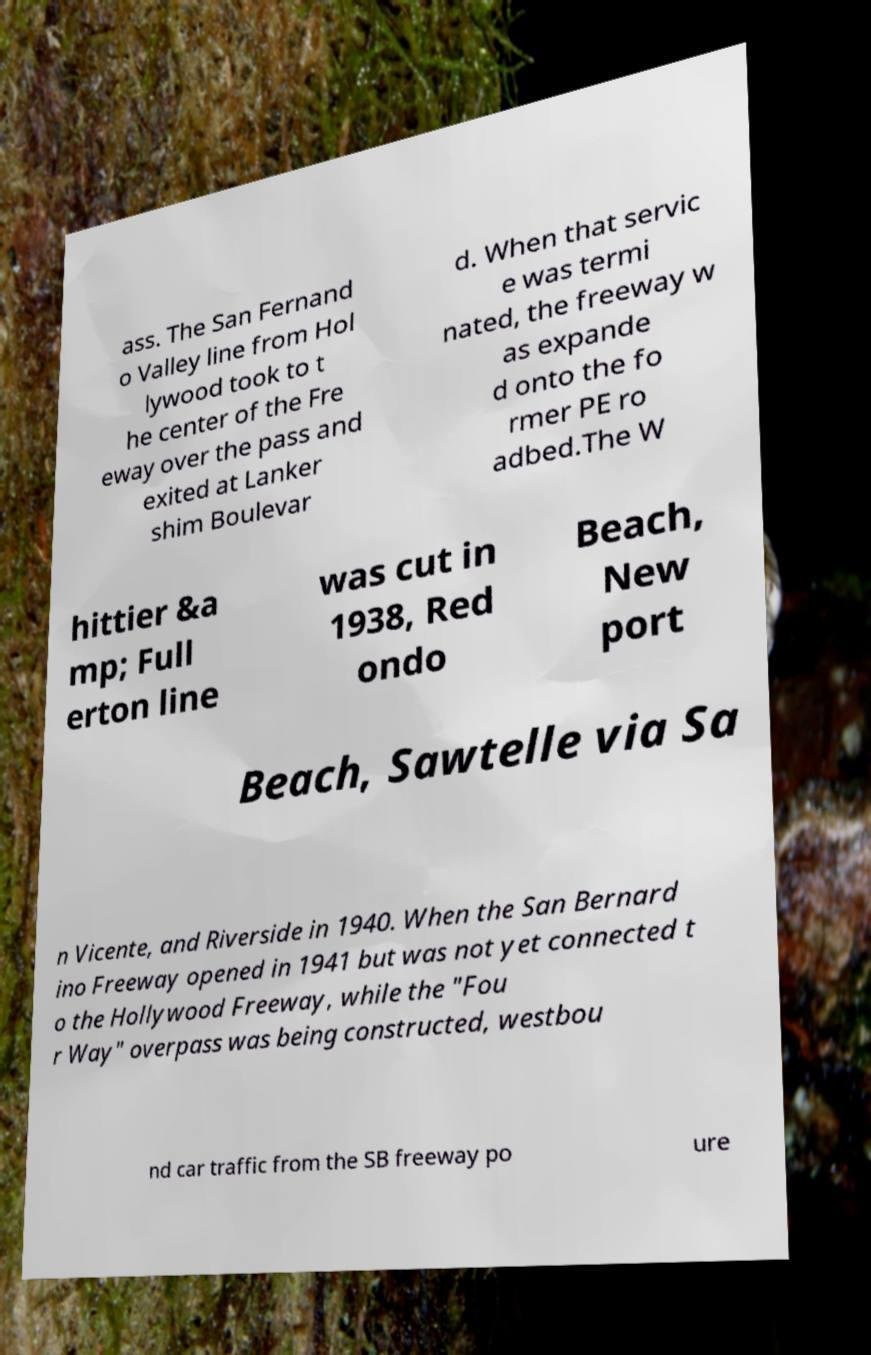For documentation purposes, I need the text within this image transcribed. Could you provide that? ass. The San Fernand o Valley line from Hol lywood took to t he center of the Fre eway over the pass and exited at Lanker shim Boulevar d. When that servic e was termi nated, the freeway w as expande d onto the fo rmer PE ro adbed.The W hittier &a mp; Full erton line was cut in 1938, Red ondo Beach, New port Beach, Sawtelle via Sa n Vicente, and Riverside in 1940. When the San Bernard ino Freeway opened in 1941 but was not yet connected t o the Hollywood Freeway, while the "Fou r Way" overpass was being constructed, westbou nd car traffic from the SB freeway po ure 